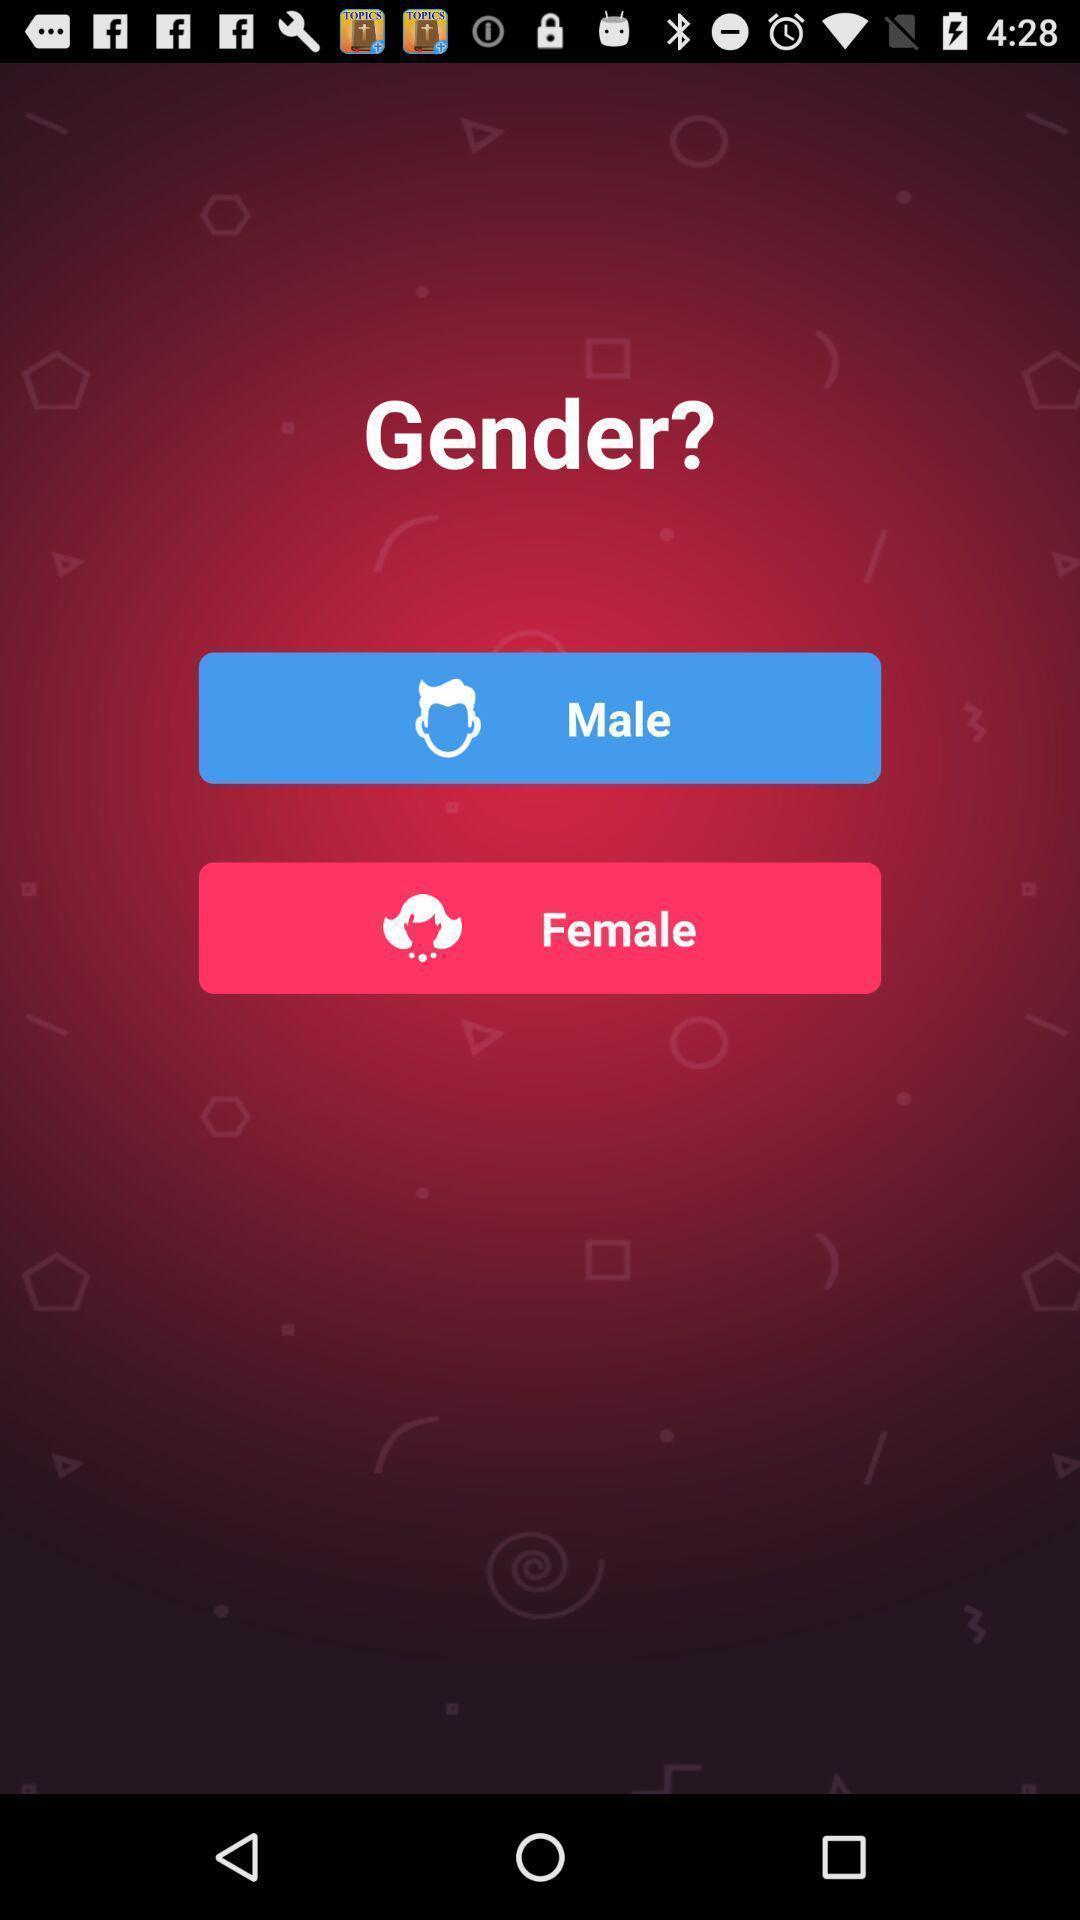Tell me about the visual elements in this screen capture. Page to select the gender. 